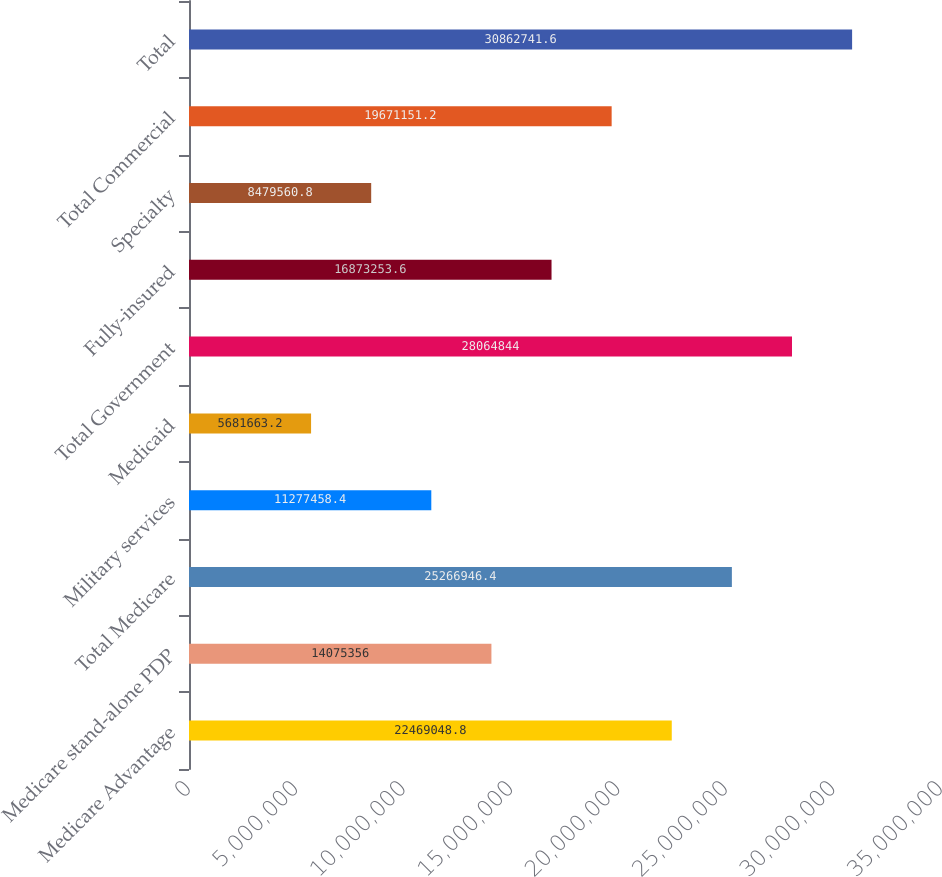Convert chart. <chart><loc_0><loc_0><loc_500><loc_500><bar_chart><fcel>Medicare Advantage<fcel>Medicare stand-alone PDP<fcel>Total Medicare<fcel>Military services<fcel>Medicaid<fcel>Total Government<fcel>Fully-insured<fcel>Specialty<fcel>Total Commercial<fcel>Total<nl><fcel>2.2469e+07<fcel>1.40754e+07<fcel>2.52669e+07<fcel>1.12775e+07<fcel>5.68166e+06<fcel>2.80648e+07<fcel>1.68733e+07<fcel>8.47956e+06<fcel>1.96712e+07<fcel>3.08627e+07<nl></chart> 